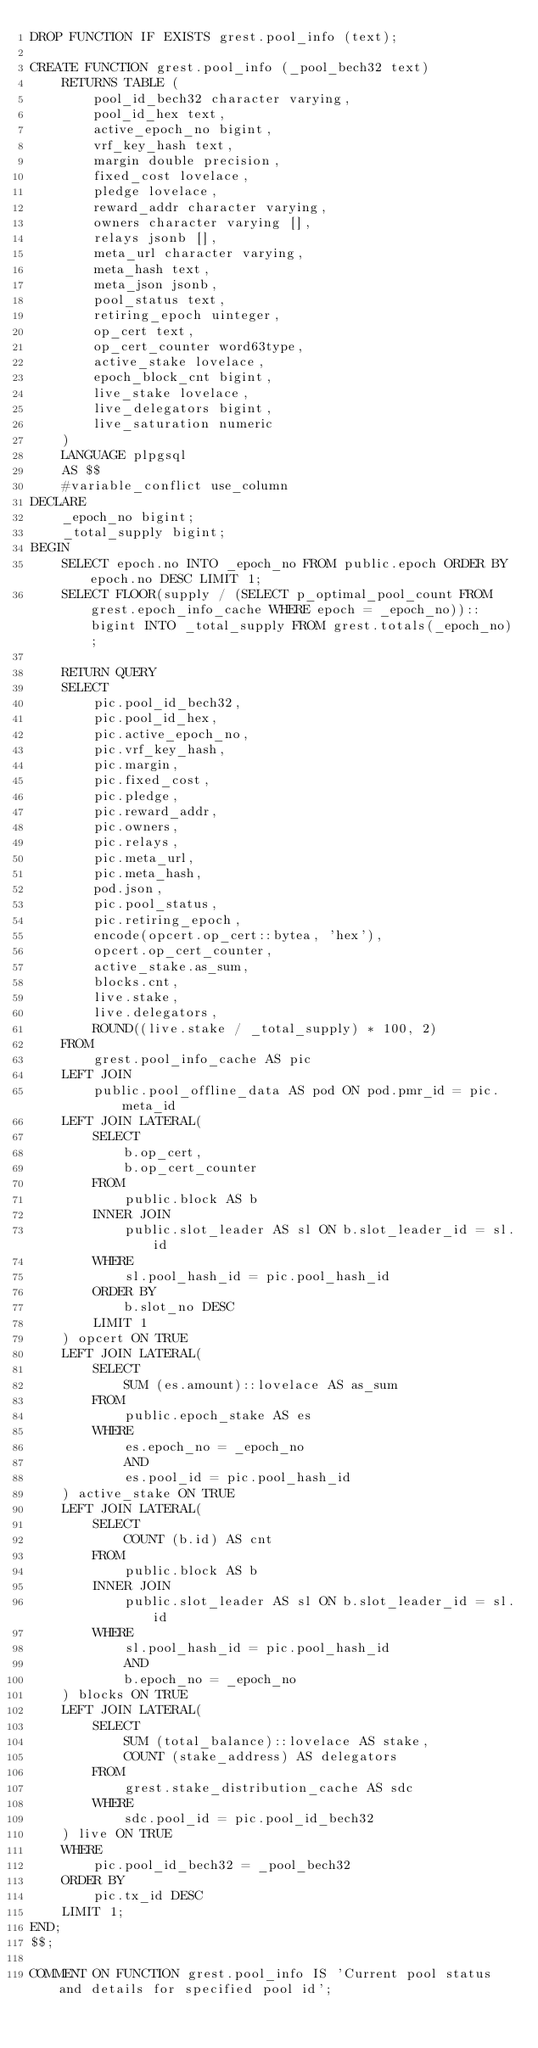Convert code to text. <code><loc_0><loc_0><loc_500><loc_500><_SQL_>DROP FUNCTION IF EXISTS grest.pool_info (text);

CREATE FUNCTION grest.pool_info (_pool_bech32 text)
    RETURNS TABLE (
        pool_id_bech32 character varying,
        pool_id_hex text,
        active_epoch_no bigint,
        vrf_key_hash text,
        margin double precision,
        fixed_cost lovelace,
        pledge lovelace,
        reward_addr character varying,
        owners character varying [],
        relays jsonb [],
        meta_url character varying,
        meta_hash text,
        meta_json jsonb,
        pool_status text,
        retiring_epoch uinteger,
        op_cert text,
        op_cert_counter word63type,
        active_stake lovelace,
        epoch_block_cnt bigint,
        live_stake lovelace,
        live_delegators bigint,
        live_saturation numeric
    )
    LANGUAGE plpgsql
    AS $$
    #variable_conflict use_column
DECLARE
    _epoch_no bigint;
    _total_supply bigint;
BEGIN
    SELECT epoch.no INTO _epoch_no FROM public.epoch ORDER BY epoch.no DESC LIMIT 1;
    SELECT FLOOR(supply / (SELECT p_optimal_pool_count FROM grest.epoch_info_cache WHERE epoch = _epoch_no))::bigint INTO _total_supply FROM grest.totals(_epoch_no);

    RETURN QUERY
    SELECT
        pic.pool_id_bech32,
        pic.pool_id_hex,
        pic.active_epoch_no,
        pic.vrf_key_hash,
        pic.margin,
        pic.fixed_cost,
        pic.pledge,
        pic.reward_addr,
        pic.owners,
        pic.relays,
        pic.meta_url,
        pic.meta_hash,
        pod.json,
        pic.pool_status,
        pic.retiring_epoch,
        encode(opcert.op_cert::bytea, 'hex'),
        opcert.op_cert_counter,
        active_stake.as_sum,
        blocks.cnt,
        live.stake,
        live.delegators,
        ROUND((live.stake / _total_supply) * 100, 2)
    FROM
        grest.pool_info_cache AS pic
    LEFT JOIN
        public.pool_offline_data AS pod ON pod.pmr_id = pic.meta_id
    LEFT JOIN LATERAL(
        SELECT 
            b.op_cert,
            b.op_cert_counter
        FROM 
            public.block AS b
        INNER JOIN 
            public.slot_leader AS sl ON b.slot_leader_id = sl.id
        WHERE
            sl.pool_hash_id = pic.pool_hash_id
        ORDER BY 
            b.slot_no DESC
        LIMIT 1
    ) opcert ON TRUE
    LEFT JOIN LATERAL(
        SELECT
            SUM (es.amount)::lovelace AS as_sum
        FROM 
            public.epoch_stake AS es
        WHERE 
            es.epoch_no = _epoch_no
            AND 
            es.pool_id = pic.pool_hash_id
    ) active_stake ON TRUE
    LEFT JOIN LATERAL(
        SELECT
            COUNT (b.id) AS cnt
        FROM 
            public.block AS b
        INNER JOIN 
            public.slot_leader AS sl ON b.slot_leader_id = sl.id
        WHERE
            sl.pool_hash_id = pic.pool_hash_id
            AND
            b.epoch_no = _epoch_no
    ) blocks ON TRUE
    LEFT JOIN LATERAL(
        SELECT
            SUM (total_balance)::lovelace AS stake,
            COUNT (stake_address) AS delegators
        FROM
            grest.stake_distribution_cache AS sdc
        WHERE
            sdc.pool_id = pic.pool_id_bech32
    ) live ON TRUE
    WHERE
        pic.pool_id_bech32 = _pool_bech32
    ORDER BY
        pic.tx_id DESC
    LIMIT 1;
END;
$$;

COMMENT ON FUNCTION grest.pool_info IS 'Current pool status and details for specified pool id';
</code> 